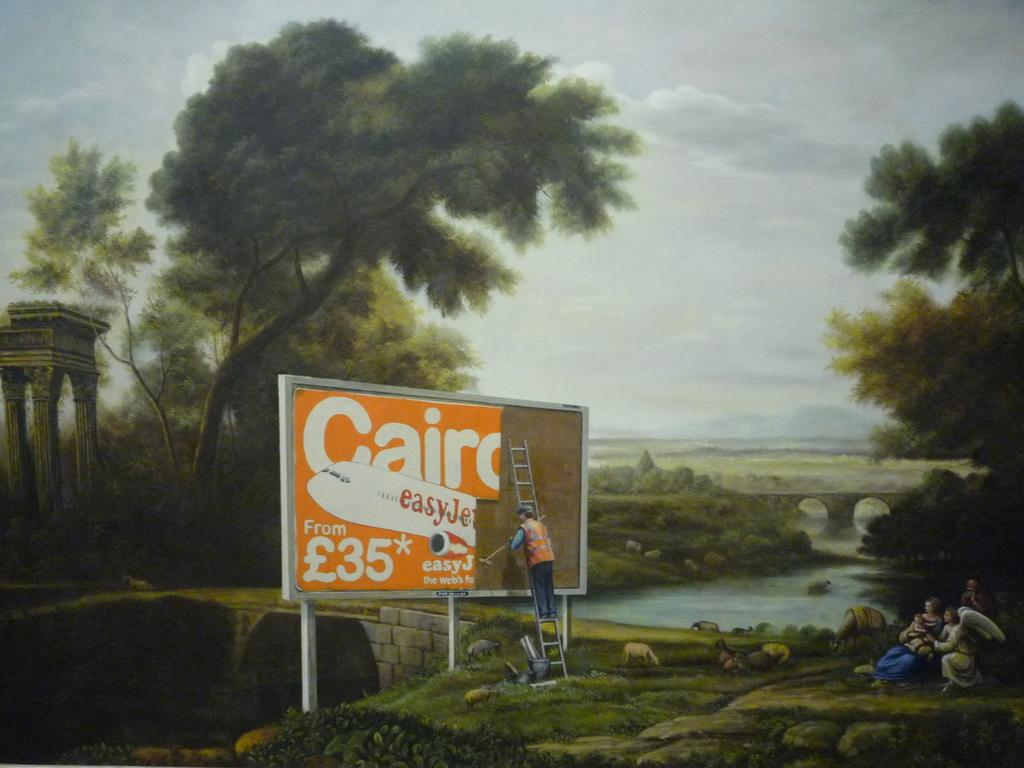What is the condition of the sky in the image? The sky is cloudy in the image. What natural element can be seen in the image? There is water visible in the image. What type of vegetation is present in the image? There are trees in the image. What type of signage is present in the image? There is a hoarding in the image. What tool is present in the image? There is a ladder in the image. How many people are in the image? There are people in the image. What man-made structure is present in the image? There is a bridge in the image. Is there anyone using the ladder in the image? Yes, there is a person on the ladder in the image. Can you tell me how many pages are in the lake in the image? There are no pages or lakes present in the image. Is there a sidewalk visible in the image? There is no sidewalk visible in the image. 